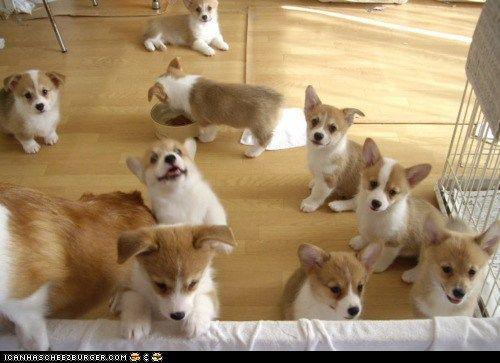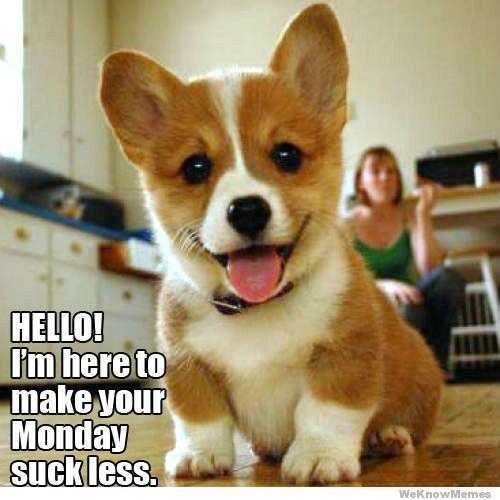The first image is the image on the left, the second image is the image on the right. Given the left and right images, does the statement "One image contains one orange-and-white corgi posed on its belly with its rear toward the camera." hold true? Answer yes or no. No. The first image is the image on the left, the second image is the image on the right. Considering the images on both sides, is "There is at least four dogs in the left image." valid? Answer yes or no. Yes. 